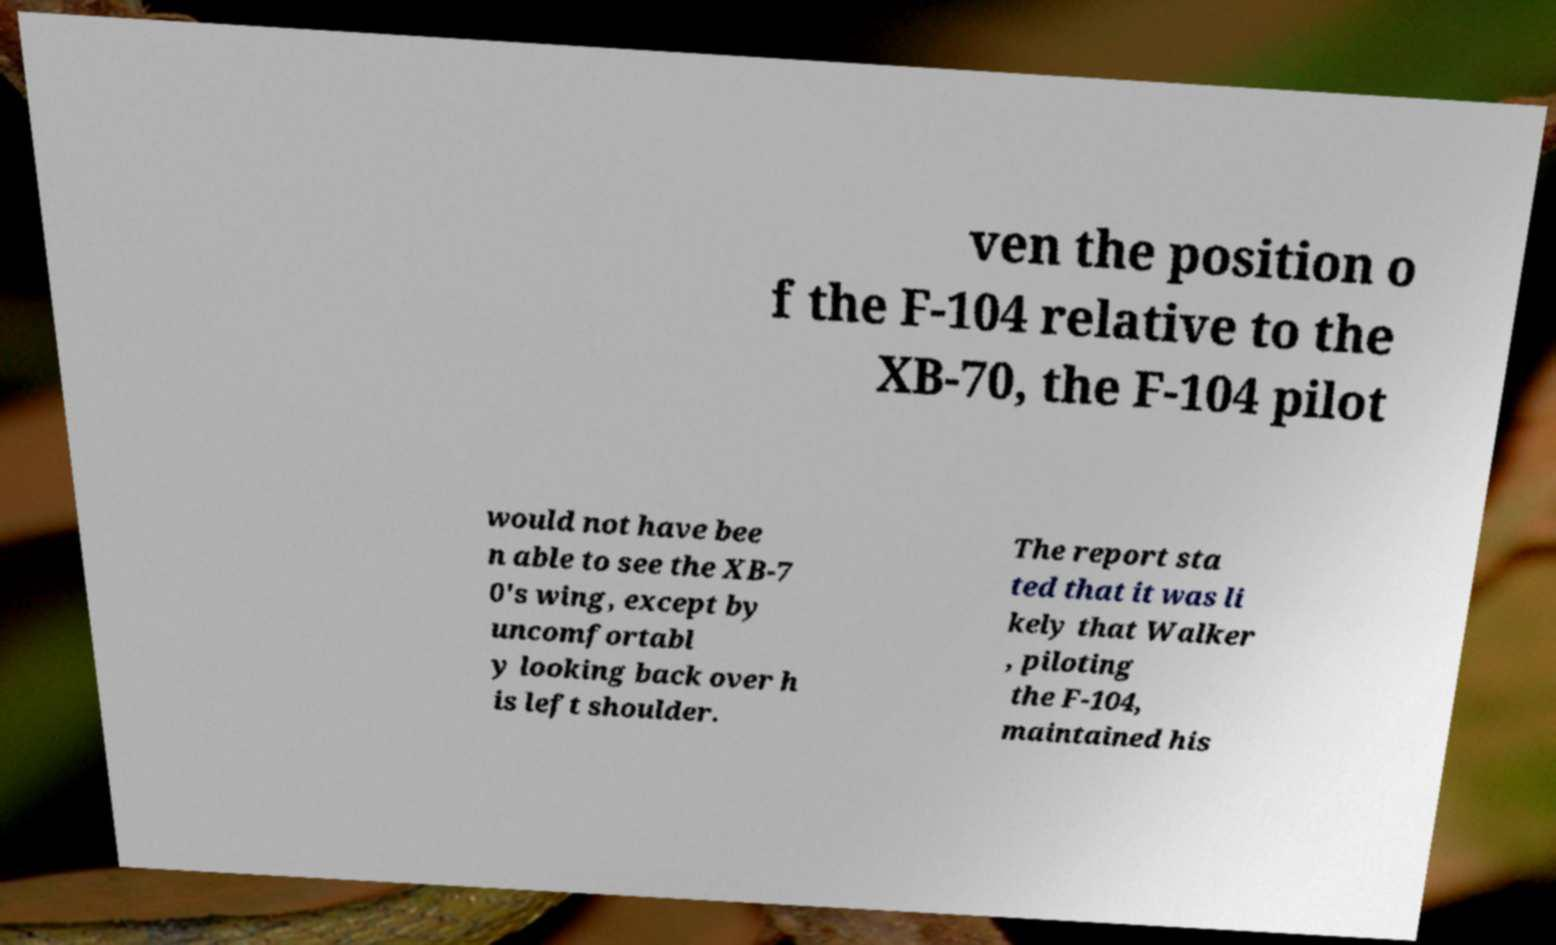There's text embedded in this image that I need extracted. Can you transcribe it verbatim? ven the position o f the F-104 relative to the XB-70, the F-104 pilot would not have bee n able to see the XB-7 0's wing, except by uncomfortabl y looking back over h is left shoulder. The report sta ted that it was li kely that Walker , piloting the F-104, maintained his 